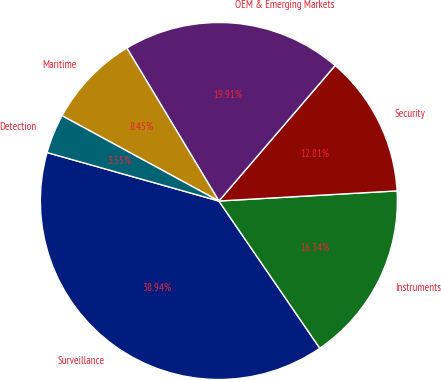Convert chart to OTSL. <chart><loc_0><loc_0><loc_500><loc_500><pie_chart><fcel>Surveillance<fcel>Instruments<fcel>Security<fcel>OEM & Emerging Markets<fcel>Maritime<fcel>Detection<nl><fcel>38.94%<fcel>16.34%<fcel>12.81%<fcel>19.91%<fcel>8.45%<fcel>3.55%<nl></chart> 